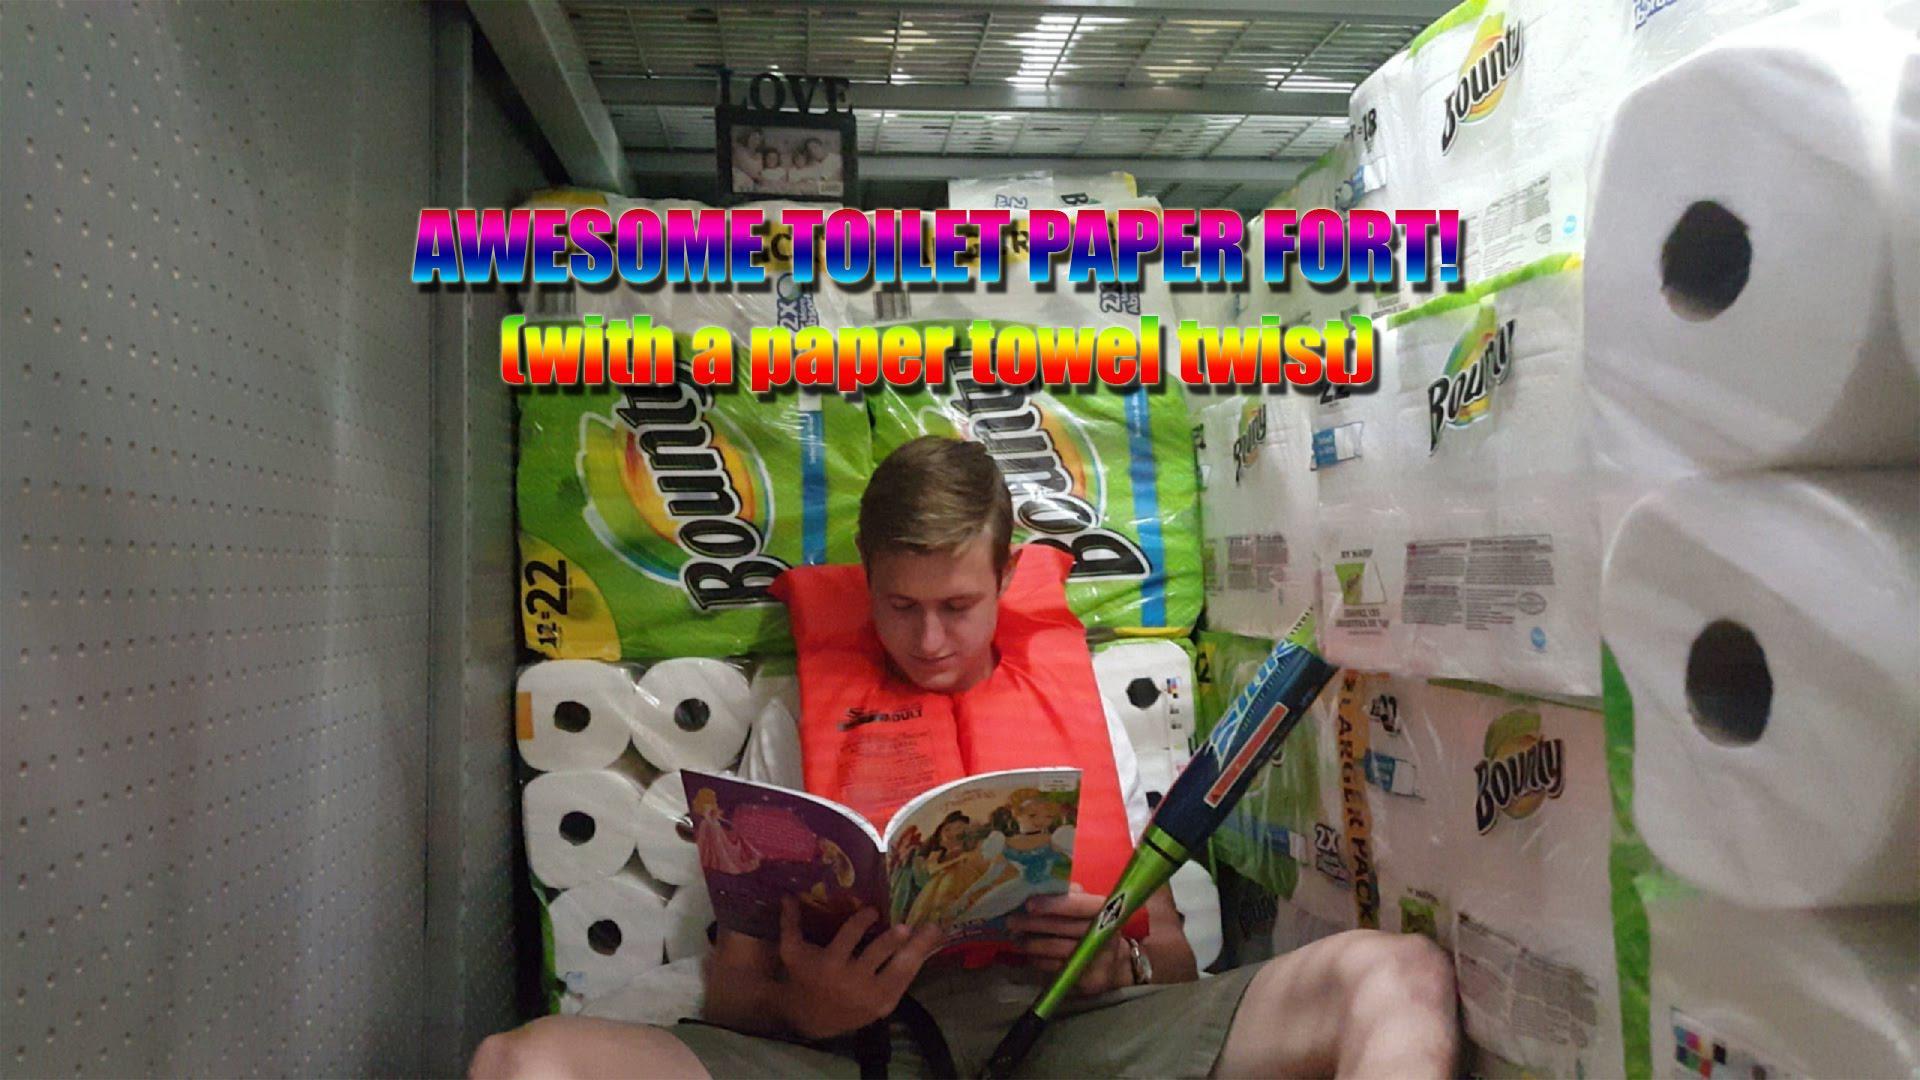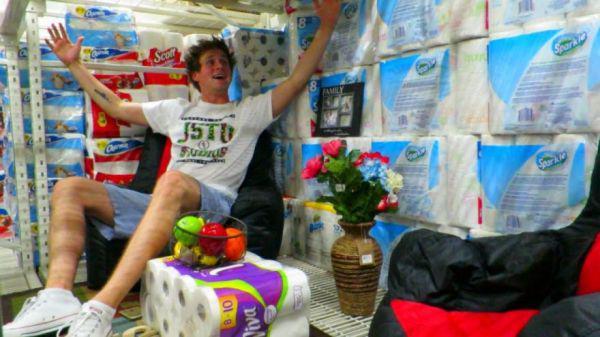The first image is the image on the left, the second image is the image on the right. Evaluate the accuracy of this statement regarding the images: "A single person sits nears piles of paper goods in the image on the right.". Is it true? Answer yes or no. Yes. 